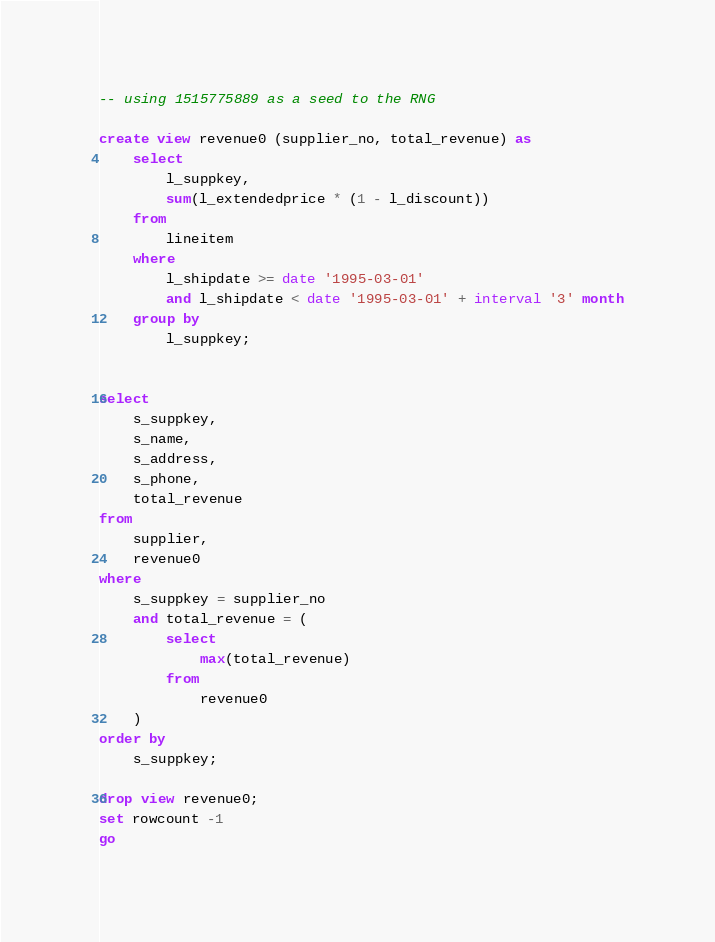<code> <loc_0><loc_0><loc_500><loc_500><_SQL_>-- using 1515775889 as a seed to the RNG

create view revenue0 (supplier_no, total_revenue) as
	select
		l_suppkey,
		sum(l_extendedprice * (1 - l_discount))
	from
		lineitem
	where
		l_shipdate >= date '1995-03-01'
		and l_shipdate < date '1995-03-01' + interval '3' month
	group by
		l_suppkey;


select
	s_suppkey,
	s_name,
	s_address,
	s_phone,
	total_revenue
from
	supplier,
	revenue0
where
	s_suppkey = supplier_no
	and total_revenue = (
		select
			max(total_revenue)
		from
			revenue0
	)
order by
	s_suppkey;

drop view revenue0;
set rowcount -1
go

</code> 